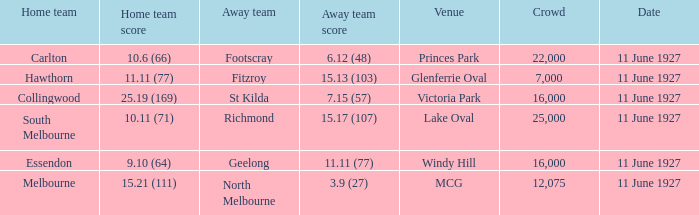How many people were in the crowd when Essendon was the home team? 1.0. 